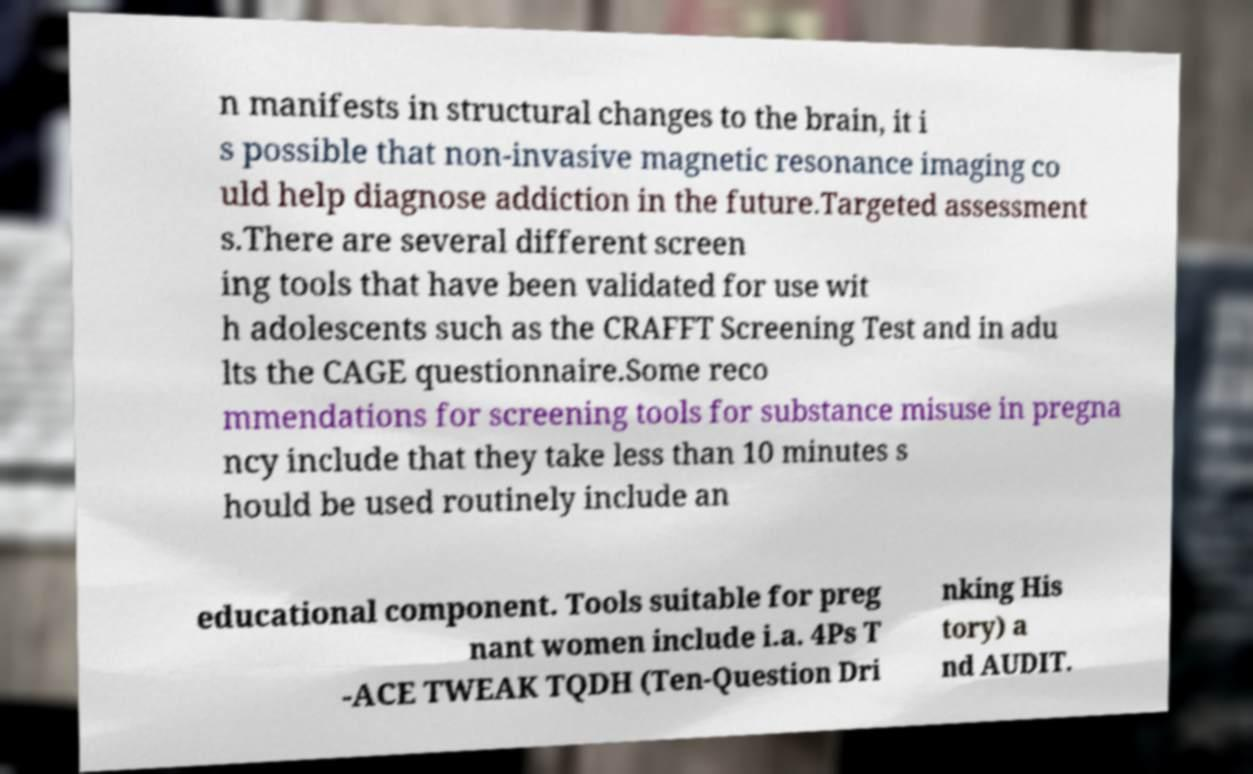I need the written content from this picture converted into text. Can you do that? n manifests in structural changes to the brain, it i s possible that non-invasive magnetic resonance imaging co uld help diagnose addiction in the future.Targeted assessment s.There are several different screen ing tools that have been validated for use wit h adolescents such as the CRAFFT Screening Test and in adu lts the CAGE questionnaire.Some reco mmendations for screening tools for substance misuse in pregna ncy include that they take less than 10 minutes s hould be used routinely include an educational component. Tools suitable for preg nant women include i.a. 4Ps T -ACE TWEAK TQDH (Ten-Question Dri nking His tory) a nd AUDIT. 